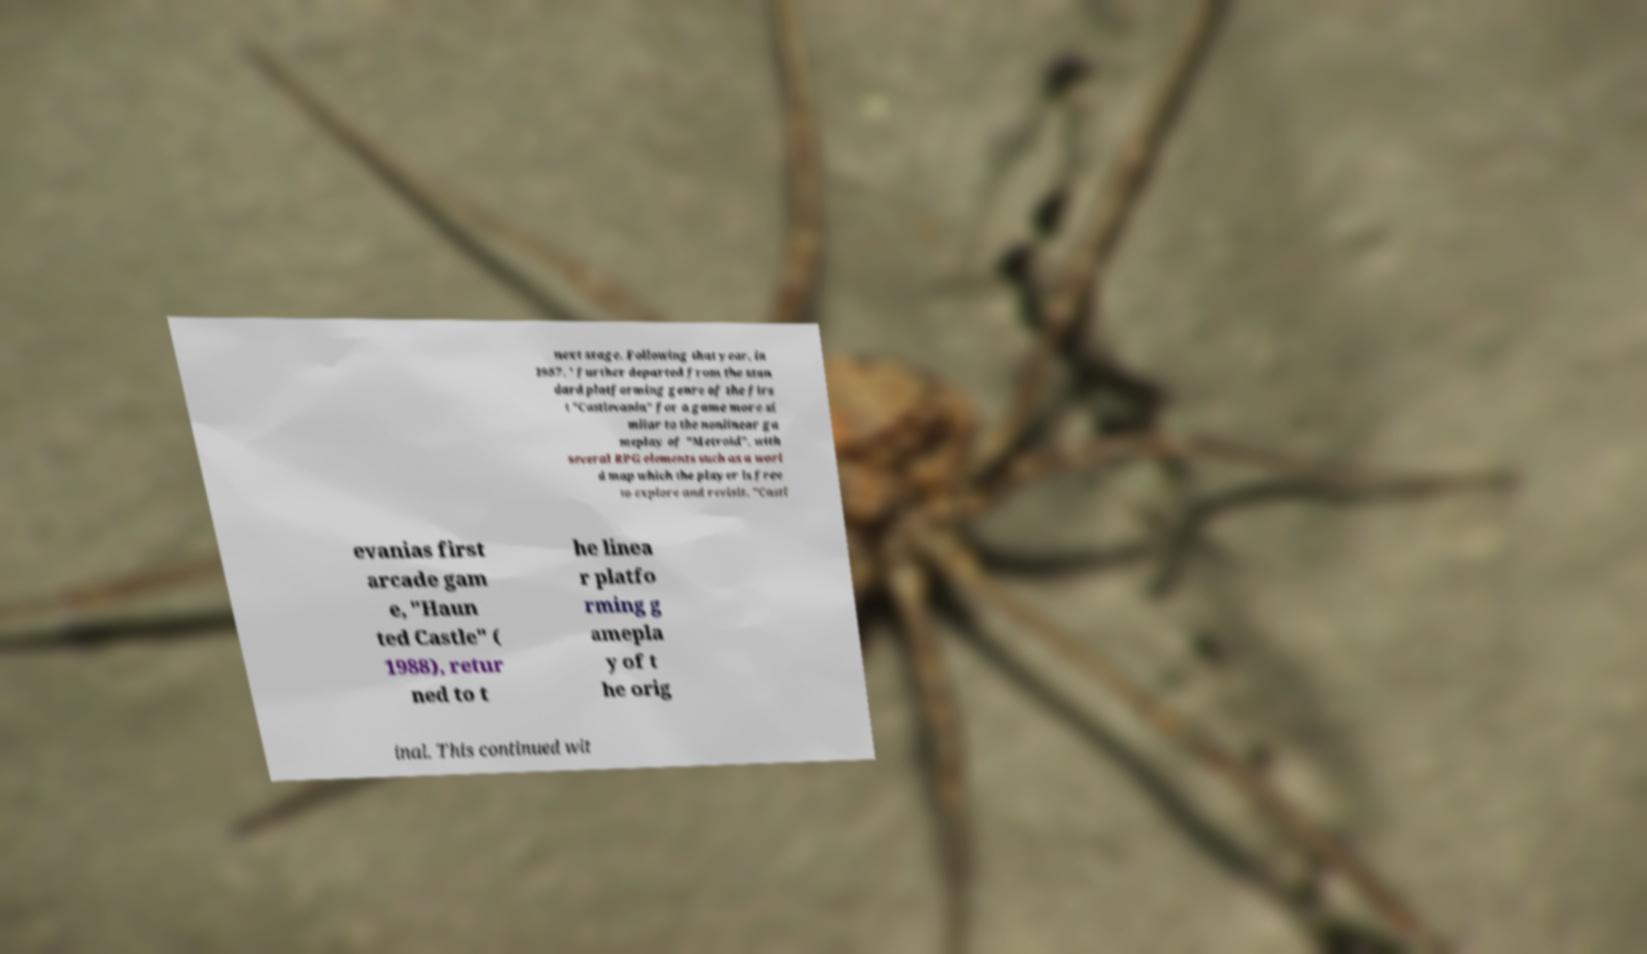Could you extract and type out the text from this image? next stage. Following that year, in 1987, ' further departed from the stan dard platforming genre of the firs t "Castlevania" for a game more si milar to the nonlinear ga meplay of "Metroid", with several RPG elements such as a worl d map which the player is free to explore and revisit. "Castl evanias first arcade gam e, "Haun ted Castle" ( 1988), retur ned to t he linea r platfo rming g amepla y of t he orig inal. This continued wit 